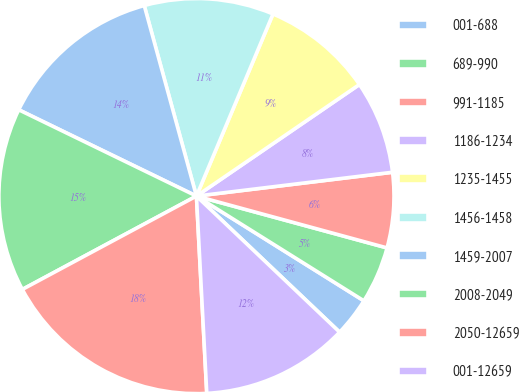<chart> <loc_0><loc_0><loc_500><loc_500><pie_chart><fcel>001-688<fcel>689-990<fcel>991-1185<fcel>1186-1234<fcel>1235-1455<fcel>1456-1458<fcel>1459-2007<fcel>2008-2049<fcel>2050-12659<fcel>001-12659<nl><fcel>3.2%<fcel>4.67%<fcel>6.15%<fcel>7.63%<fcel>9.11%<fcel>10.59%<fcel>13.55%<fcel>15.03%<fcel>18.0%<fcel>12.07%<nl></chart> 